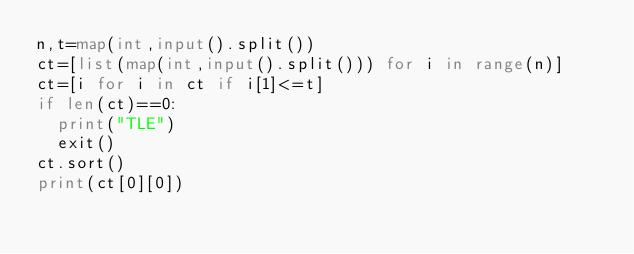<code> <loc_0><loc_0><loc_500><loc_500><_Python_>n,t=map(int,input().split())
ct=[list(map(int,input().split())) for i in range(n)]
ct=[i for i in ct if i[1]<=t]
if len(ct)==0:
  print("TLE")
  exit()
ct.sort()
print(ct[0][0])
</code> 